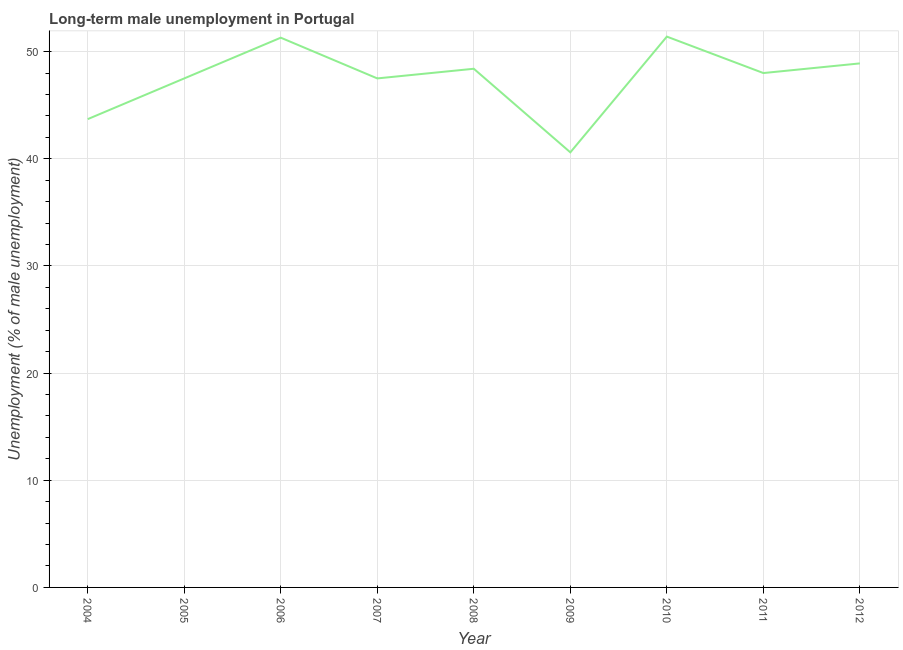What is the long-term male unemployment in 2006?
Offer a terse response. 51.3. Across all years, what is the maximum long-term male unemployment?
Offer a very short reply. 51.4. Across all years, what is the minimum long-term male unemployment?
Make the answer very short. 40.6. In which year was the long-term male unemployment maximum?
Provide a short and direct response. 2010. In which year was the long-term male unemployment minimum?
Your response must be concise. 2009. What is the sum of the long-term male unemployment?
Your response must be concise. 427.3. What is the difference between the long-term male unemployment in 2004 and 2011?
Provide a succinct answer. -4.3. What is the average long-term male unemployment per year?
Your answer should be compact. 47.48. What is the median long-term male unemployment?
Your answer should be very brief. 48. In how many years, is the long-term male unemployment greater than 40 %?
Your answer should be compact. 9. Do a majority of the years between 2006 and 2005 (inclusive) have long-term male unemployment greater than 14 %?
Keep it short and to the point. No. What is the ratio of the long-term male unemployment in 2004 to that in 2007?
Offer a very short reply. 0.92. Is the difference between the long-term male unemployment in 2007 and 2010 greater than the difference between any two years?
Your answer should be compact. No. What is the difference between the highest and the second highest long-term male unemployment?
Give a very brief answer. 0.1. Is the sum of the long-term male unemployment in 2006 and 2012 greater than the maximum long-term male unemployment across all years?
Your response must be concise. Yes. What is the difference between the highest and the lowest long-term male unemployment?
Give a very brief answer. 10.8. Does the long-term male unemployment monotonically increase over the years?
Make the answer very short. No. How many lines are there?
Provide a short and direct response. 1. Does the graph contain any zero values?
Provide a succinct answer. No. Does the graph contain grids?
Provide a succinct answer. Yes. What is the title of the graph?
Make the answer very short. Long-term male unemployment in Portugal. What is the label or title of the X-axis?
Your answer should be compact. Year. What is the label or title of the Y-axis?
Your answer should be very brief. Unemployment (% of male unemployment). What is the Unemployment (% of male unemployment) of 2004?
Your answer should be very brief. 43.7. What is the Unemployment (% of male unemployment) of 2005?
Ensure brevity in your answer.  47.5. What is the Unemployment (% of male unemployment) of 2006?
Give a very brief answer. 51.3. What is the Unemployment (% of male unemployment) in 2007?
Make the answer very short. 47.5. What is the Unemployment (% of male unemployment) of 2008?
Offer a very short reply. 48.4. What is the Unemployment (% of male unemployment) of 2009?
Offer a terse response. 40.6. What is the Unemployment (% of male unemployment) of 2010?
Your answer should be very brief. 51.4. What is the Unemployment (% of male unemployment) of 2011?
Your response must be concise. 48. What is the Unemployment (% of male unemployment) of 2012?
Keep it short and to the point. 48.9. What is the difference between the Unemployment (% of male unemployment) in 2004 and 2008?
Offer a terse response. -4.7. What is the difference between the Unemployment (% of male unemployment) in 2004 and 2009?
Your answer should be compact. 3.1. What is the difference between the Unemployment (% of male unemployment) in 2004 and 2011?
Keep it short and to the point. -4.3. What is the difference between the Unemployment (% of male unemployment) in 2005 and 2007?
Your answer should be very brief. 0. What is the difference between the Unemployment (% of male unemployment) in 2005 and 2008?
Provide a short and direct response. -0.9. What is the difference between the Unemployment (% of male unemployment) in 2006 and 2007?
Your response must be concise. 3.8. What is the difference between the Unemployment (% of male unemployment) in 2006 and 2008?
Ensure brevity in your answer.  2.9. What is the difference between the Unemployment (% of male unemployment) in 2006 and 2009?
Ensure brevity in your answer.  10.7. What is the difference between the Unemployment (% of male unemployment) in 2006 and 2010?
Give a very brief answer. -0.1. What is the difference between the Unemployment (% of male unemployment) in 2006 and 2011?
Offer a very short reply. 3.3. What is the difference between the Unemployment (% of male unemployment) in 2006 and 2012?
Offer a very short reply. 2.4. What is the difference between the Unemployment (% of male unemployment) in 2007 and 2008?
Your answer should be very brief. -0.9. What is the difference between the Unemployment (% of male unemployment) in 2007 and 2009?
Your answer should be very brief. 6.9. What is the difference between the Unemployment (% of male unemployment) in 2008 and 2009?
Offer a terse response. 7.8. What is the difference between the Unemployment (% of male unemployment) in 2008 and 2012?
Your answer should be very brief. -0.5. What is the difference between the Unemployment (% of male unemployment) in 2009 and 2011?
Your response must be concise. -7.4. What is the difference between the Unemployment (% of male unemployment) in 2009 and 2012?
Ensure brevity in your answer.  -8.3. What is the ratio of the Unemployment (% of male unemployment) in 2004 to that in 2006?
Your answer should be very brief. 0.85. What is the ratio of the Unemployment (% of male unemployment) in 2004 to that in 2007?
Provide a succinct answer. 0.92. What is the ratio of the Unemployment (% of male unemployment) in 2004 to that in 2008?
Ensure brevity in your answer.  0.9. What is the ratio of the Unemployment (% of male unemployment) in 2004 to that in 2009?
Ensure brevity in your answer.  1.08. What is the ratio of the Unemployment (% of male unemployment) in 2004 to that in 2010?
Provide a succinct answer. 0.85. What is the ratio of the Unemployment (% of male unemployment) in 2004 to that in 2011?
Give a very brief answer. 0.91. What is the ratio of the Unemployment (% of male unemployment) in 2004 to that in 2012?
Ensure brevity in your answer.  0.89. What is the ratio of the Unemployment (% of male unemployment) in 2005 to that in 2006?
Give a very brief answer. 0.93. What is the ratio of the Unemployment (% of male unemployment) in 2005 to that in 2008?
Offer a very short reply. 0.98. What is the ratio of the Unemployment (% of male unemployment) in 2005 to that in 2009?
Your answer should be very brief. 1.17. What is the ratio of the Unemployment (% of male unemployment) in 2005 to that in 2010?
Your answer should be very brief. 0.92. What is the ratio of the Unemployment (% of male unemployment) in 2006 to that in 2008?
Keep it short and to the point. 1.06. What is the ratio of the Unemployment (% of male unemployment) in 2006 to that in 2009?
Your answer should be compact. 1.26. What is the ratio of the Unemployment (% of male unemployment) in 2006 to that in 2010?
Ensure brevity in your answer.  1. What is the ratio of the Unemployment (% of male unemployment) in 2006 to that in 2011?
Your answer should be very brief. 1.07. What is the ratio of the Unemployment (% of male unemployment) in 2006 to that in 2012?
Keep it short and to the point. 1.05. What is the ratio of the Unemployment (% of male unemployment) in 2007 to that in 2009?
Give a very brief answer. 1.17. What is the ratio of the Unemployment (% of male unemployment) in 2007 to that in 2010?
Your answer should be compact. 0.92. What is the ratio of the Unemployment (% of male unemployment) in 2008 to that in 2009?
Your response must be concise. 1.19. What is the ratio of the Unemployment (% of male unemployment) in 2008 to that in 2010?
Provide a short and direct response. 0.94. What is the ratio of the Unemployment (% of male unemployment) in 2009 to that in 2010?
Offer a terse response. 0.79. What is the ratio of the Unemployment (% of male unemployment) in 2009 to that in 2011?
Offer a very short reply. 0.85. What is the ratio of the Unemployment (% of male unemployment) in 2009 to that in 2012?
Offer a very short reply. 0.83. What is the ratio of the Unemployment (% of male unemployment) in 2010 to that in 2011?
Your response must be concise. 1.07. What is the ratio of the Unemployment (% of male unemployment) in 2010 to that in 2012?
Ensure brevity in your answer.  1.05. 